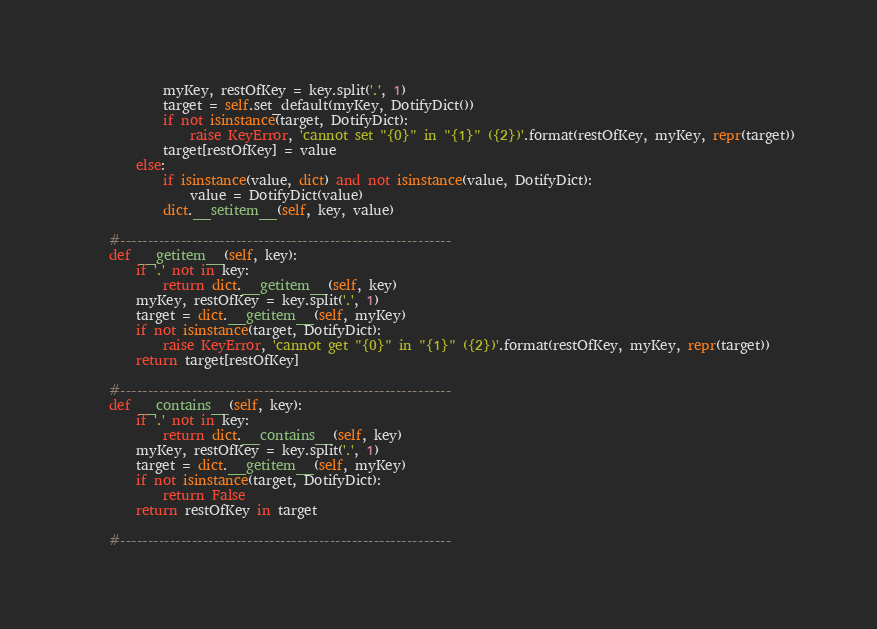<code> <loc_0><loc_0><loc_500><loc_500><_Python_>            myKey, restOfKey = key.split('.', 1)
            target = self.set_default(myKey, DotifyDict())
            if not isinstance(target, DotifyDict):
                raise KeyError, 'cannot set "{0}" in "{1}" ({2})'.format(restOfKey, myKey, repr(target))
            target[restOfKey] = value
        else:
            if isinstance(value, dict) and not isinstance(value, DotifyDict):
                value = DotifyDict(value)
            dict.__setitem__(self, key, value)
    
    #------------------------------------------------------------
    def __getitem__(self, key):
        if '.' not in key:
            return dict.__getitem__(self, key)
        myKey, restOfKey = key.split('.', 1)
        target = dict.__getitem__(self, myKey)
        if not isinstance(target, DotifyDict):
            raise KeyError, 'cannot get "{0}" in "{1}" ({2})'.format(restOfKey, myKey, repr(target))
        return target[restOfKey]
    
    #------------------------------------------------------------
    def __contains__(self, key):
        if '.' not in key:
            return dict.__contains__(self, key)
        myKey, restOfKey = key.split('.', 1)
        target = dict.__getitem__(self, myKey)
        if not isinstance(target, DotifyDict):
            return False
        return restOfKey in target
    
    #------------------------------------------------------------</code> 